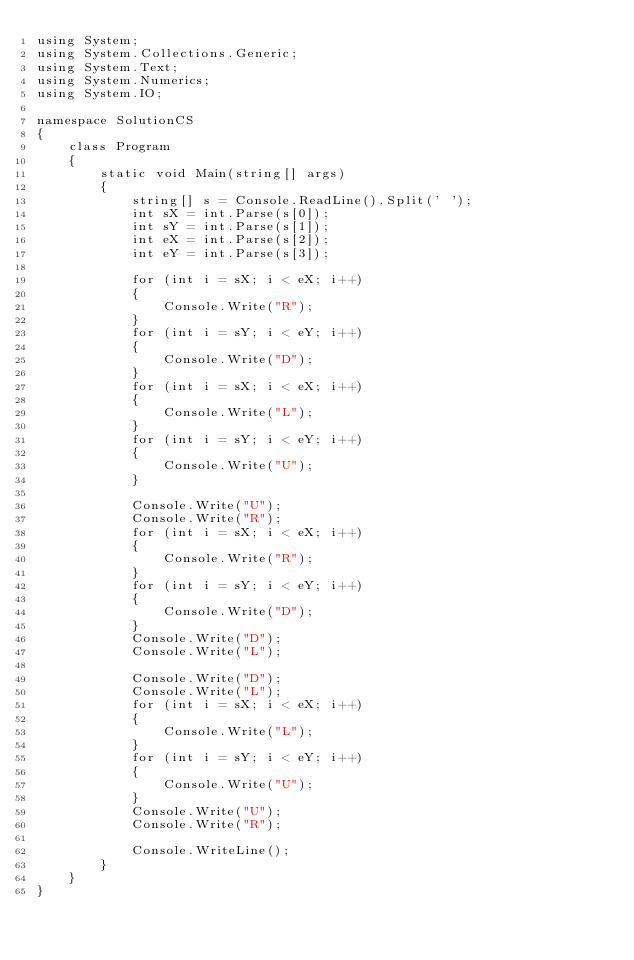Convert code to text. <code><loc_0><loc_0><loc_500><loc_500><_C#_>using System;
using System.Collections.Generic;
using System.Text;
using System.Numerics;
using System.IO;

namespace SolutionCS
{
    class Program
    {
        static void Main(string[] args)
        {
            string[] s = Console.ReadLine().Split(' ');
            int sX = int.Parse(s[0]);
            int sY = int.Parse(s[1]);
            int eX = int.Parse(s[2]);
            int eY = int.Parse(s[3]);

            for (int i = sX; i < eX; i++)
            {
                Console.Write("R");
            }
            for (int i = sY; i < eY; i++)
            {
                Console.Write("D");
            }
            for (int i = sX; i < eX; i++)
            {
                Console.Write("L");
            }
            for (int i = sY; i < eY; i++)
            {
                Console.Write("U");
            }

            Console.Write("U");
            Console.Write("R");
            for (int i = sX; i < eX; i++)
            {
                Console.Write("R");
            }
            for (int i = sY; i < eY; i++)
            {
                Console.Write("D");
            }
            Console.Write("D");
            Console.Write("L");

            Console.Write("D");
            Console.Write("L");
            for (int i = sX; i < eX; i++)
            {
                Console.Write("L");
            }
            for (int i = sY; i < eY; i++)
            {
                Console.Write("U");
            }
            Console.Write("U");
            Console.Write("R");

            Console.WriteLine();
        }
    }
}
</code> 